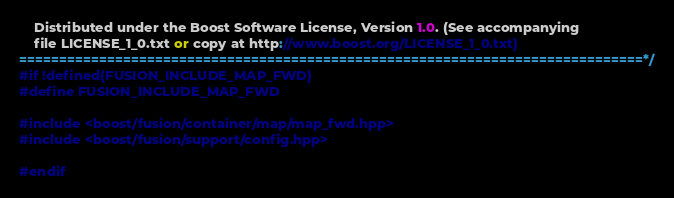Convert code to text. <code><loc_0><loc_0><loc_500><loc_500><_C++_>
    Distributed under the Boost Software License, Version 1.0. (See accompanying
    file LICENSE_1_0.txt or copy at http://www.boost.org/LICENSE_1_0.txt)
==============================================================================*/
#if !defined(FUSION_INCLUDE_MAP_FWD)
#define FUSION_INCLUDE_MAP_FWD

#include <boost/fusion/container/map/map_fwd.hpp>
#include <boost/fusion/support/config.hpp>

#endif
</code> 